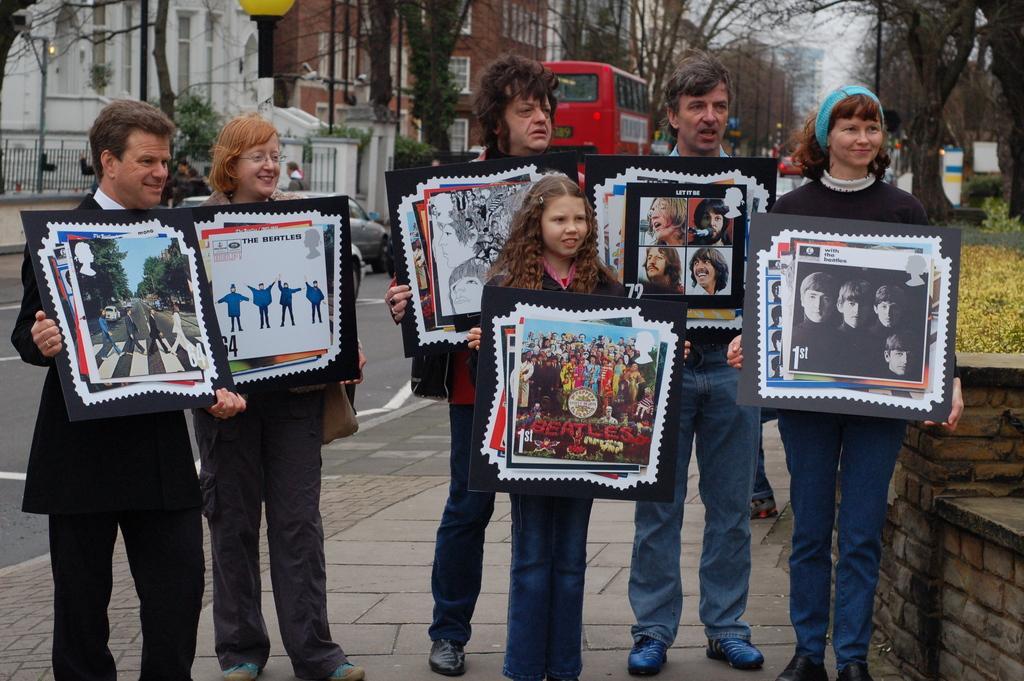Can you describe this image briefly? In this image we can see some people are standing on the footpath and holding some posters in their hands. 